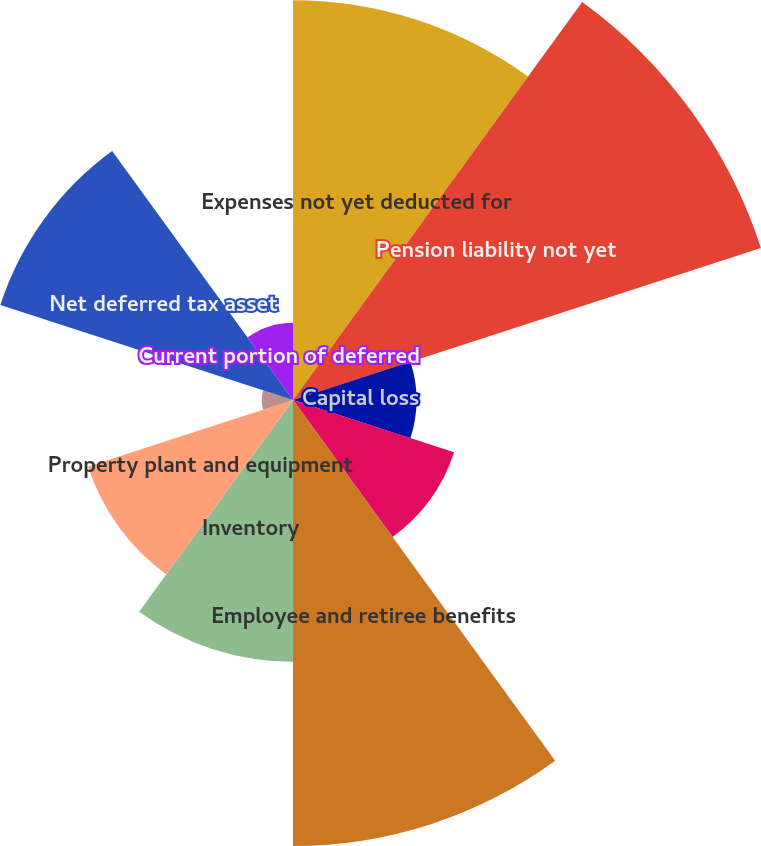Convert chart. <chart><loc_0><loc_0><loc_500><loc_500><pie_chart><fcel>Expenses not yet deducted for<fcel>Pension liability not yet<fcel>Capital loss<fcel>Valuation allowance<fcel>Employee and retiree benefits<fcel>Inventory<fcel>Property plant and equipment<fcel>Other<fcel>Net deferred tax asset<fcel>Current portion of deferred<nl><fcel>15.84%<fcel>19.49%<fcel>4.89%<fcel>6.71%<fcel>17.67%<fcel>10.37%<fcel>8.54%<fcel>1.24%<fcel>12.19%<fcel>3.06%<nl></chart> 